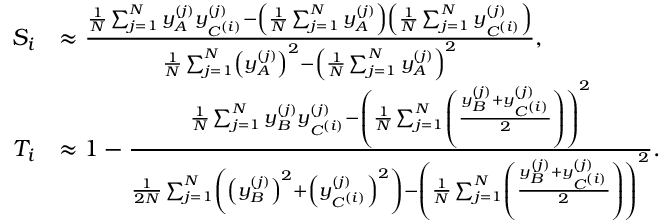Convert formula to latex. <formula><loc_0><loc_0><loc_500><loc_500>\begin{array} { r l } { S _ { i } } & { \approx \frac { \frac { 1 } { N } \sum _ { j = 1 } ^ { N } y _ { A } ^ { ( j ) } y _ { C ^ { ( i ) } } ^ { ( j ) } - \left ( \frac { 1 } { N } \sum _ { j = 1 } ^ { N } y _ { A } ^ { ( j ) } \right ) \left ( \frac { 1 } { N } \sum _ { j = 1 } ^ { N } y _ { C ^ { ( i ) } } ^ { ( j ) } \right ) } { \frac { 1 } { N } \sum _ { j = 1 } ^ { N } \left ( y _ { A } ^ { ( j ) } \right ) ^ { 2 } - \left ( \frac { 1 } { N } \sum _ { j = 1 } ^ { N } y _ { A } ^ { ( j ) } \right ) ^ { 2 } } , } \\ { T _ { i } } & { \approx 1 - \frac { \frac { 1 } { N } \sum _ { j = 1 } ^ { N } y _ { B } ^ { ( j ) } y _ { C ^ { ( i ) } } ^ { ( j ) } - \left ( \frac { 1 } { N } \sum _ { j = 1 } ^ { N } \left ( \frac { y _ { B } ^ { ( j ) } + y _ { C ^ { ( i ) } } ^ { ( j ) } } { 2 } \right ) \right ) ^ { 2 } } { \frac { 1 } { 2 N } \sum _ { j = 1 } ^ { N } \left ( \left ( y _ { B } ^ { ( j ) } \right ) ^ { 2 } + \left ( y _ { C ^ { ( i ) } } ^ { ( j ) } \right ) ^ { 2 } \right ) - \left ( \frac { 1 } { N } \sum _ { j = 1 } ^ { N } \left ( \frac { y _ { B } ^ { ( j ) } + y _ { C ^ { ( i ) } } ^ { ( j ) } } { 2 } \right ) \right ) ^ { 2 } } . } \end{array}</formula> 